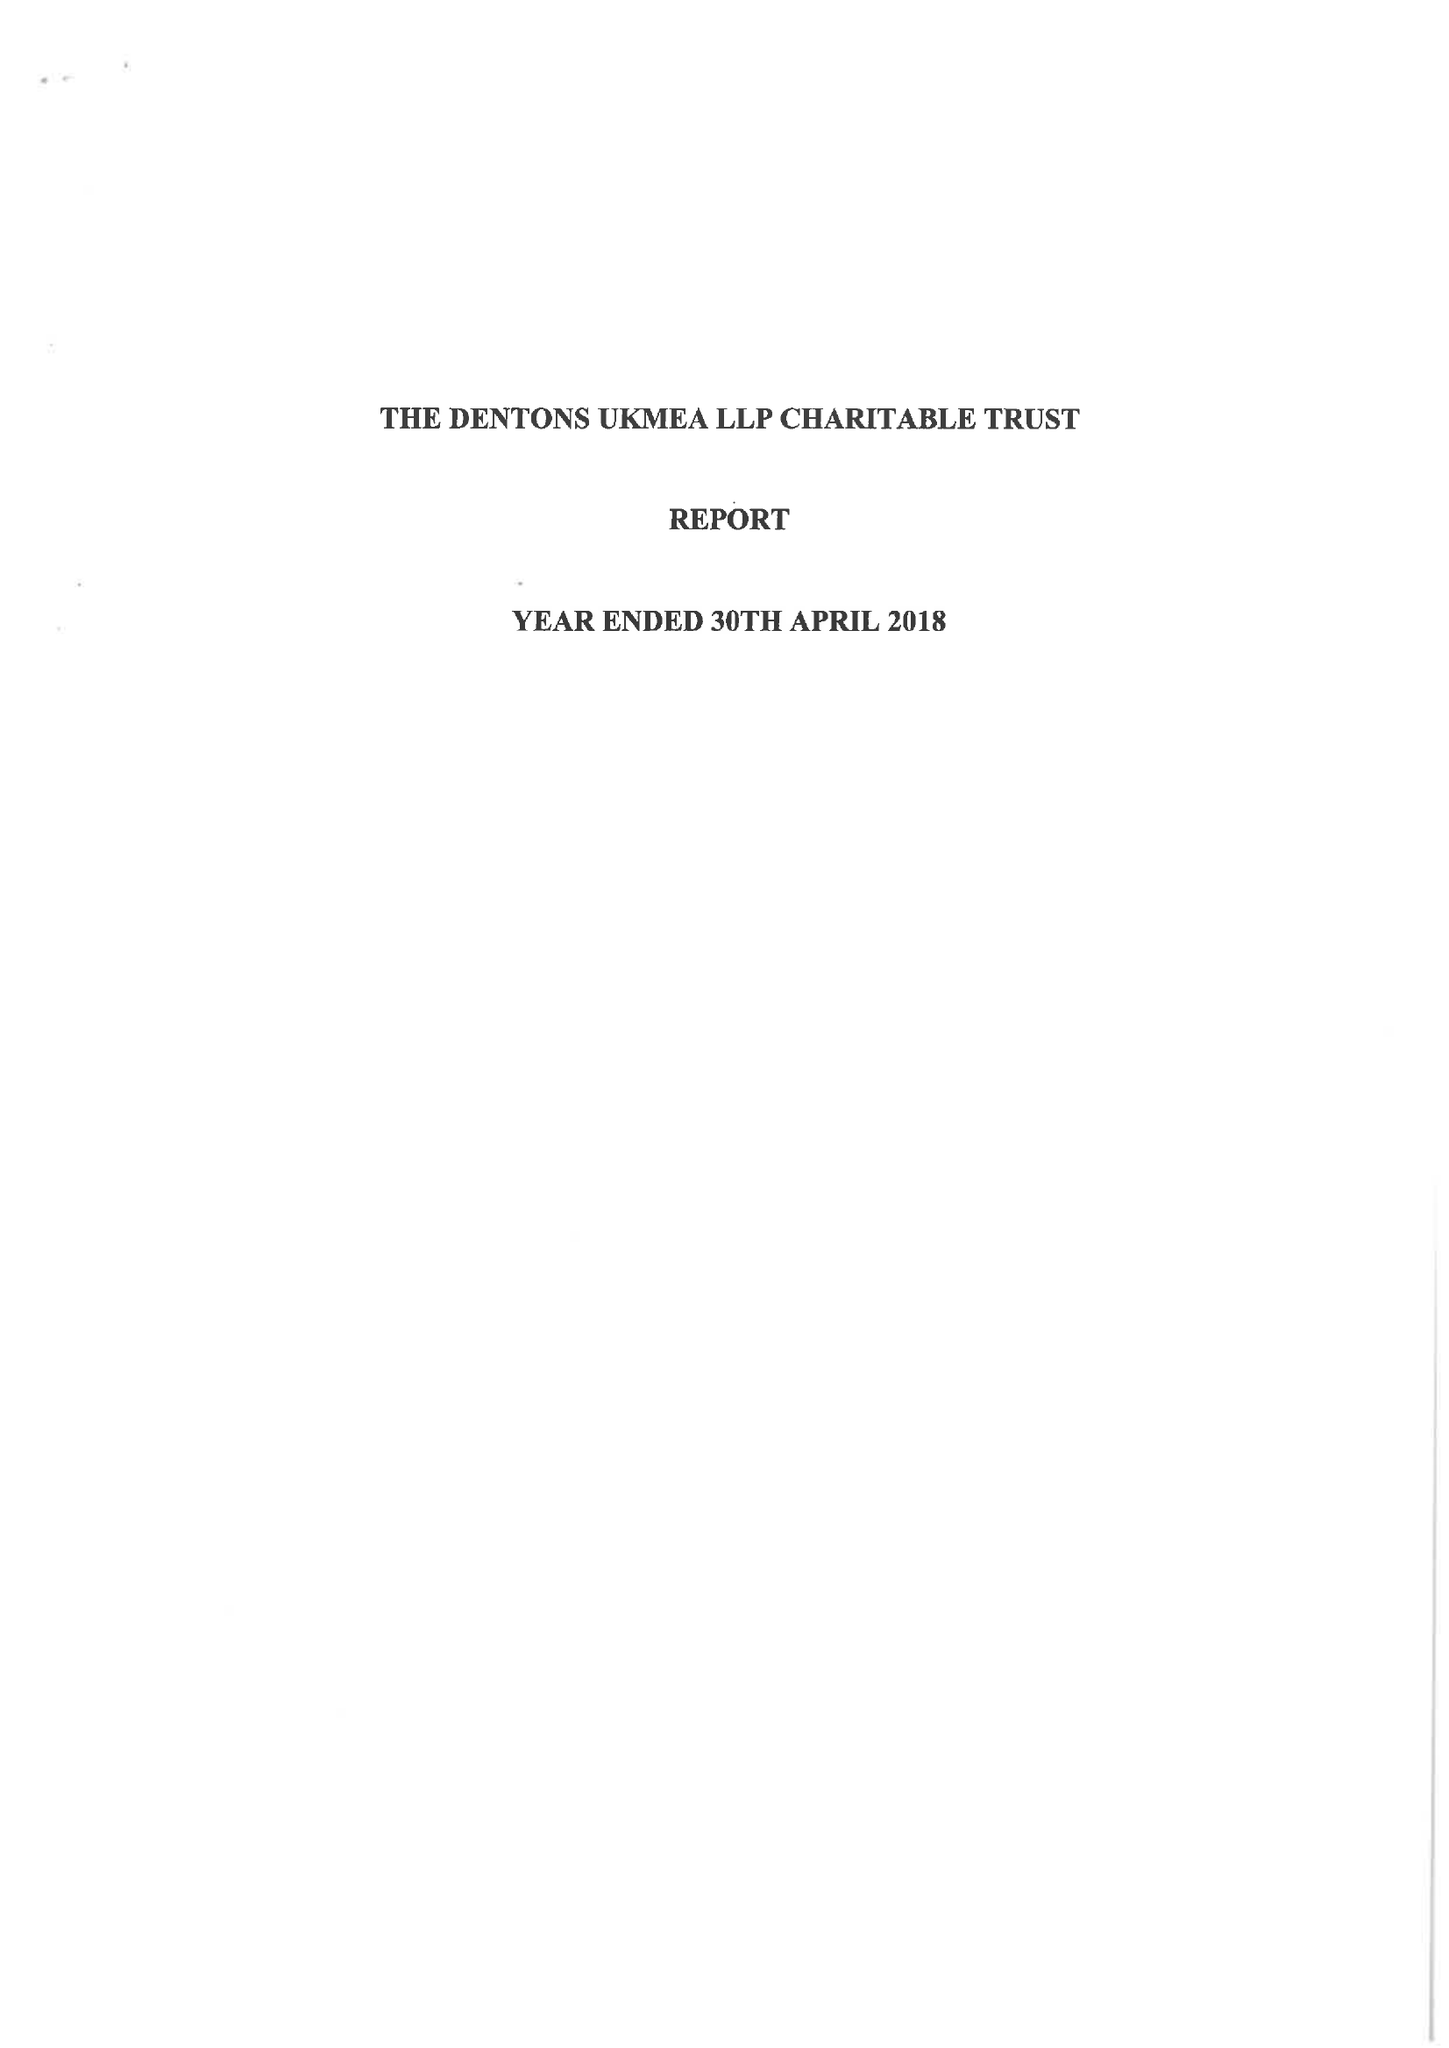What is the value for the income_annually_in_british_pounds?
Answer the question using a single word or phrase. 140154.00 